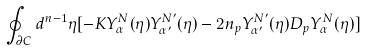<formula> <loc_0><loc_0><loc_500><loc_500>\oint _ { \partial C } d ^ { n - 1 } { \eta } [ - K Y _ { \alpha } ^ { N } ( \eta ) Y _ { \alpha ^ { \prime } } ^ { N ^ { \prime } } ( \eta ) - 2 n _ { p } Y _ { \alpha ^ { \prime } } ^ { N ^ { \prime } } ( \eta ) D _ { p } Y _ { \alpha } ^ { N } ( \eta ) ]</formula> 